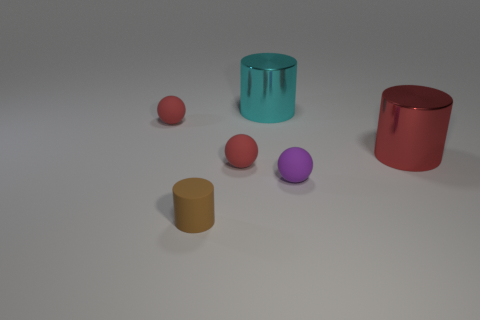How many red things are spheres or big metallic cylinders?
Provide a succinct answer. 3. What number of big cyan metal things are behind the large cyan metal thing?
Give a very brief answer. 0. What is the size of the rubber sphere to the right of the red matte object on the right side of the matte ball that is left of the small cylinder?
Make the answer very short. Small. There is a tiny red sphere that is behind the tiny red sphere that is to the right of the small brown matte cylinder; are there any large shiny cylinders left of it?
Offer a very short reply. No. Is the number of tiny red rubber objects greater than the number of cyan objects?
Your response must be concise. Yes. The tiny rubber thing on the right side of the big cyan cylinder is what color?
Make the answer very short. Purple. Is the number of rubber cylinders that are behind the cyan cylinder greater than the number of tiny blue cubes?
Provide a succinct answer. No. Does the large red thing have the same material as the purple ball?
Make the answer very short. No. What number of other objects are the same shape as the purple rubber object?
Give a very brief answer. 2. There is a metal object in front of the red rubber object that is behind the metal thing that is to the right of the tiny purple object; what color is it?
Make the answer very short. Red. 